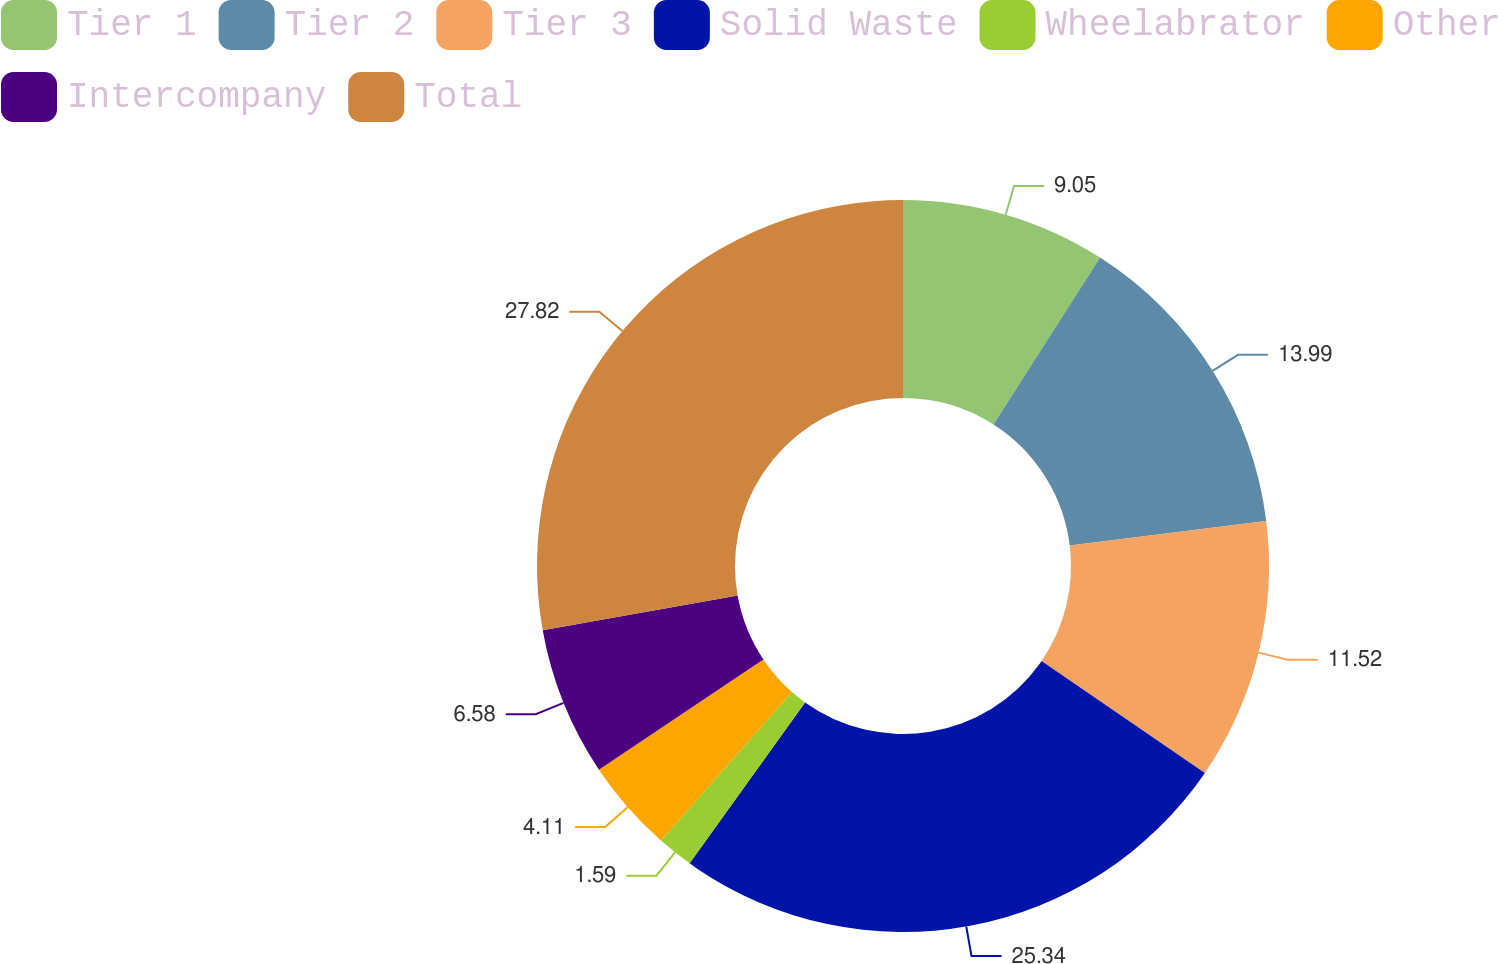Convert chart to OTSL. <chart><loc_0><loc_0><loc_500><loc_500><pie_chart><fcel>Tier 1<fcel>Tier 2<fcel>Tier 3<fcel>Solid Waste<fcel>Wheelabrator<fcel>Other<fcel>Intercompany<fcel>Total<nl><fcel>9.05%<fcel>13.99%<fcel>11.52%<fcel>25.34%<fcel>1.59%<fcel>4.11%<fcel>6.58%<fcel>27.81%<nl></chart> 